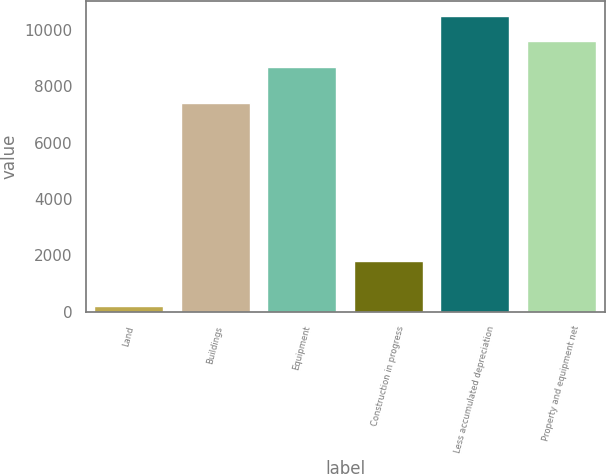Convert chart. <chart><loc_0><loc_0><loc_500><loc_500><bar_chart><fcel>Land<fcel>Buildings<fcel>Equipment<fcel>Construction in progress<fcel>Less accumulated depreciation<fcel>Property and equipment net<nl><fcel>192.7<fcel>7425.6<fcel>8689<fcel>1783.8<fcel>10503.4<fcel>9596.19<nl></chart> 